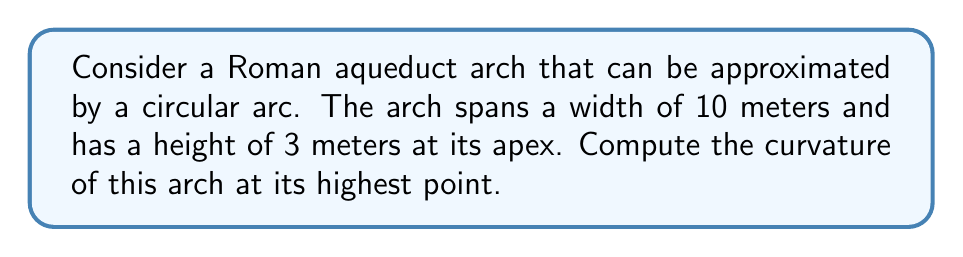Give your solution to this math problem. To solve this problem, we'll follow these steps:

1) First, we need to understand that the curvature of a circle is the reciprocal of its radius. So, if we can find the radius of the circle that forms this arch, we can determine its curvature.

2) The arch forms part of a circle. We can consider it as a circular segment where:
   - The width of the arch is the chord of this segment
   - The height of the arch is the height of the segment

3) Let's define our variables:
   $w$ = width of the arch = 10 meters
   $h$ = height of the arch = 3 meters
   $r$ = radius of the circle (unknown)

4) We can use the equation for the height of a circular segment:

   $$h = r - \sqrt{r^2 - (\frac{w}{2})^2}$$

5) Substituting our known values:

   $$3 = r - \sqrt{r^2 - 5^2}$$

6) Solving this equation:
   
   $$3 = r - \sqrt{r^2 - 25}$$
   $$\sqrt{r^2 - 25} = r - 3$$
   $$(r^2 - 25) = (r - 3)^2$$
   $$r^2 - 25 = r^2 - 6r + 9$$
   $$6r = 34$$
   $$r = \frac{17}{3} \approx 5.67 \text{ meters}$$

7) Now that we have the radius, we can compute the curvature. The curvature $\kappa$ is the reciprocal of the radius:

   $$\kappa = \frac{1}{r} = \frac{3}{17} \approx 0.176 \text{ m}^{-1}$$

[asy]
import geometry;

size(200);

real r = 5.67;
real w = 10;
real h = 3;

pair O = (0, r-h);
pair A = (-w/2, 0);
pair B = (w/2, 0);
pair C = (0, h);

draw(Circle(O, r), blue);
draw(A--B, red);
draw(O--C, dashed);
draw(O--A, dashed);
draw(O--B, dashed);

label("O", O, N);
label("A", A, SW);
label("B", B, SE);
label("C", C, N);
label("r", (O+C)/2, E);
label("w", (A+B)/2, S);
label("h", (0,0), E);

[/asy]
Answer: The curvature of the Roman aqueduct arch at its highest point is $\frac{3}{17} \approx 0.176 \text{ m}^{-1}$. 